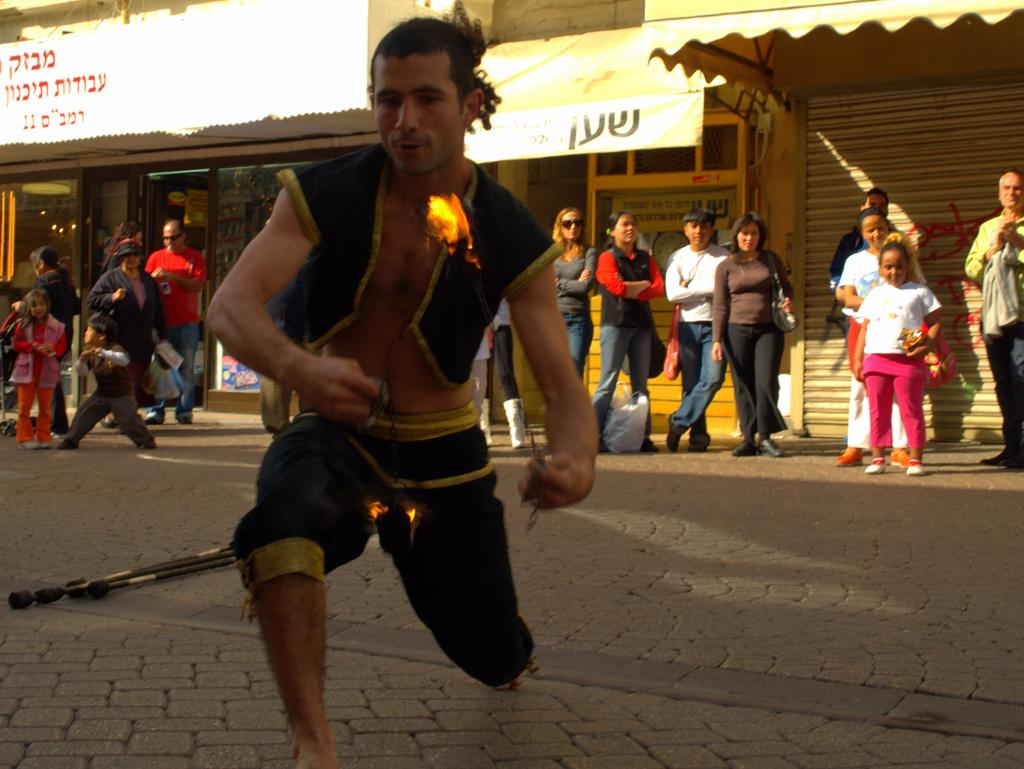What is located at the bottom of the image? There is a road at the bottom of the image. What can be seen in the middle of the image? People are standing in the middle of the image. What advice is being given in the image? There is no indication in the image that any advice is being given. Is this image taken in a park? The provided facts do not mention a park, so it cannot be determined from the image. 